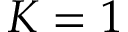<formula> <loc_0><loc_0><loc_500><loc_500>K = 1</formula> 